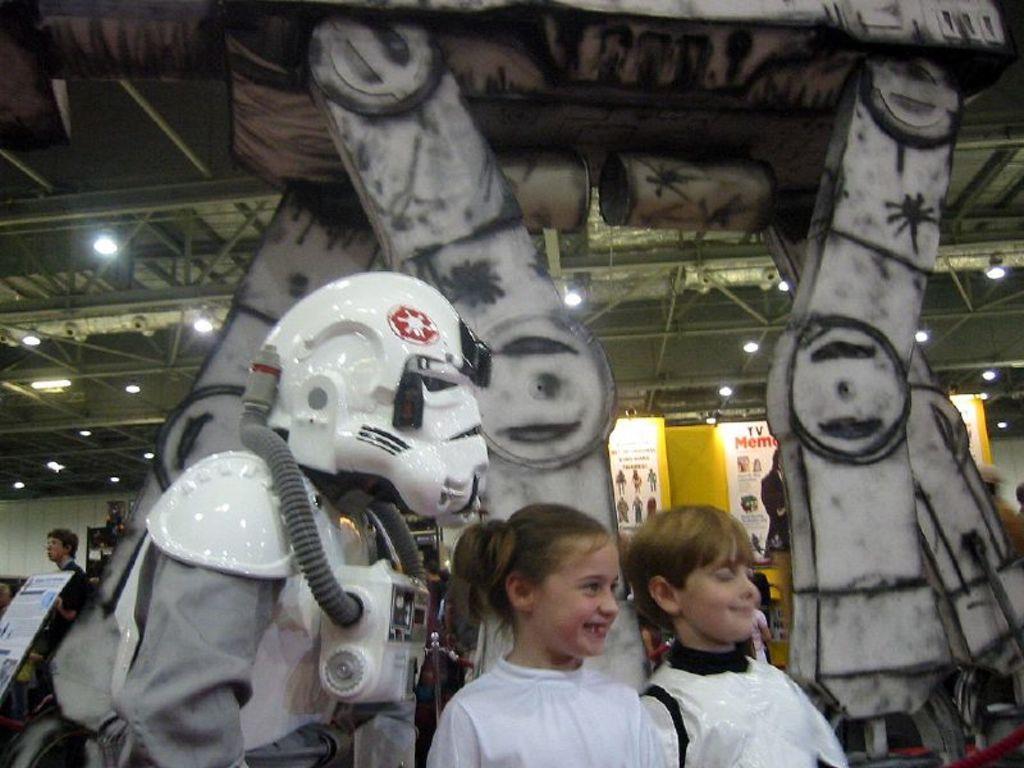Could you give a brief overview of what you see in this image? In this image, at the bottom there is a girl, boy, they are smiling. On the left it seems like a person robot. In the background there are people, posters, boards, lights, roof, machine. 